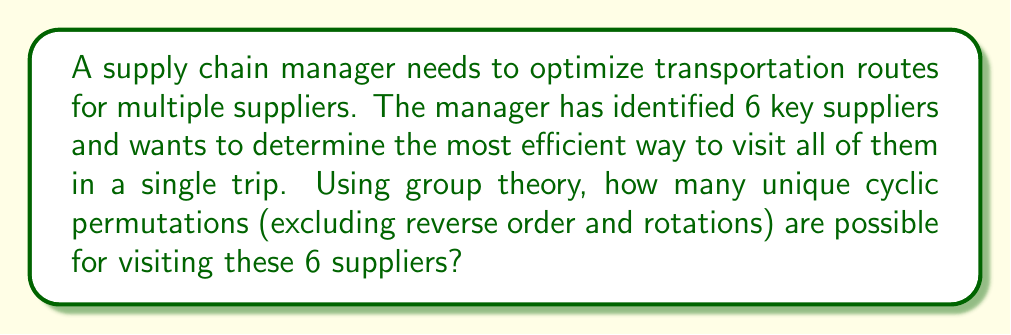Can you answer this question? To solve this problem, we can use concepts from group theory, specifically cyclic permutations and the orbit-stabilizer theorem.

1. First, we need to understand that we're dealing with cyclic permutations of 6 elements (suppliers). In a cyclic permutation, the order matters, but the starting point doesn't.

2. The total number of permutations of 6 elements is 6! = 720. However, this includes permutations that are equivalent when considered as cycles.

3. In cyclic permutations, rotations of the same sequence are considered equivalent. For example, (123456), (234561), and (345612) are all considered the same cyclic permutation.

4. The number of rotations for each permutation is equal to the number of elements, which is 6 in this case.

5. Additionally, we need to exclude reverse orders. For example, (123456) and (654321) are considered the same route for optimization purposes.

6. Using the orbit-stabilizer theorem from group theory, we can calculate the number of unique cyclic permutations:

   $$ \text{Number of unique cycles} = \frac{(n-1)!}{2} $$

   Where n is the number of elements.

7. Substituting n = 6 into this formula:

   $$ \text{Number of unique cycles} = \frac{(6-1)!}{2} = \frac{5!}{2} = \frac{120}{2} = 60 $$

Therefore, there are 60 unique cyclic permutations for visiting the 6 suppliers.
Answer: 60 unique cyclic permutations 